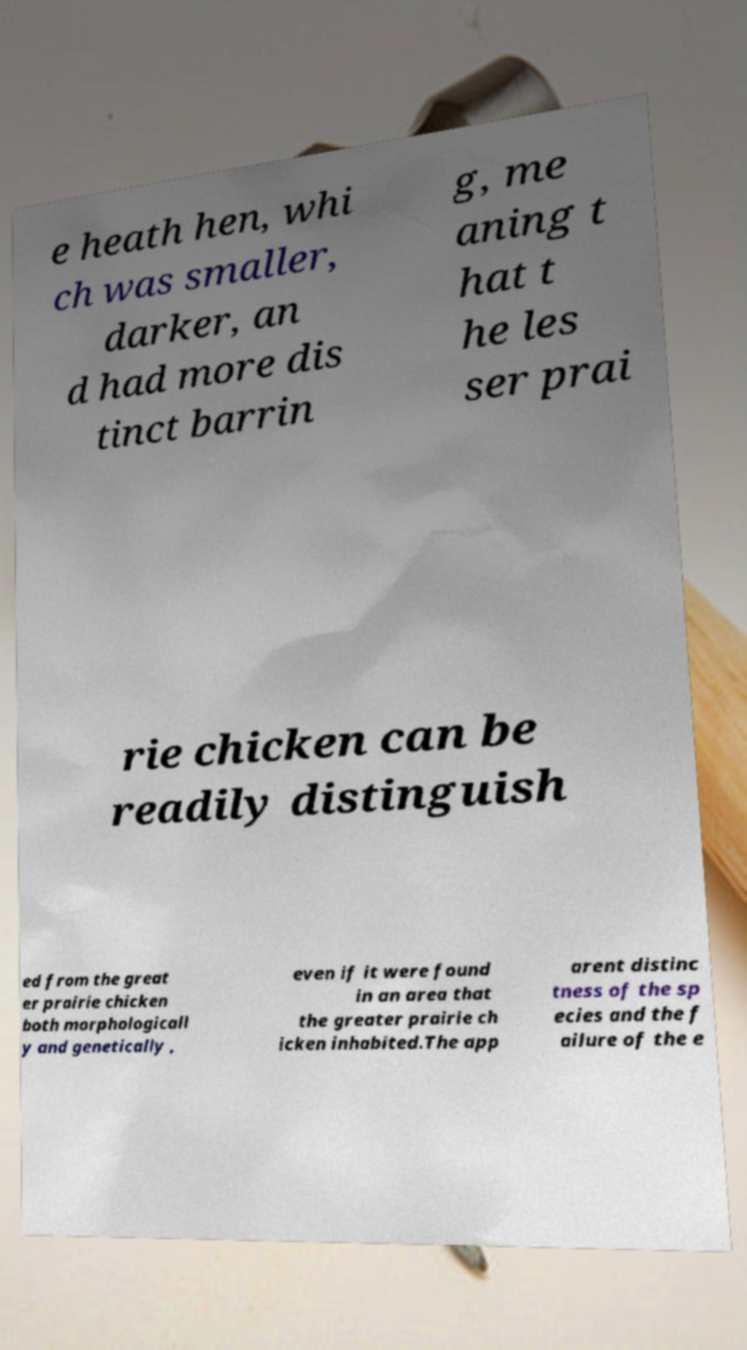I need the written content from this picture converted into text. Can you do that? e heath hen, whi ch was smaller, darker, an d had more dis tinct barrin g, me aning t hat t he les ser prai rie chicken can be readily distinguish ed from the great er prairie chicken both morphologicall y and genetically , even if it were found in an area that the greater prairie ch icken inhabited.The app arent distinc tness of the sp ecies and the f ailure of the e 